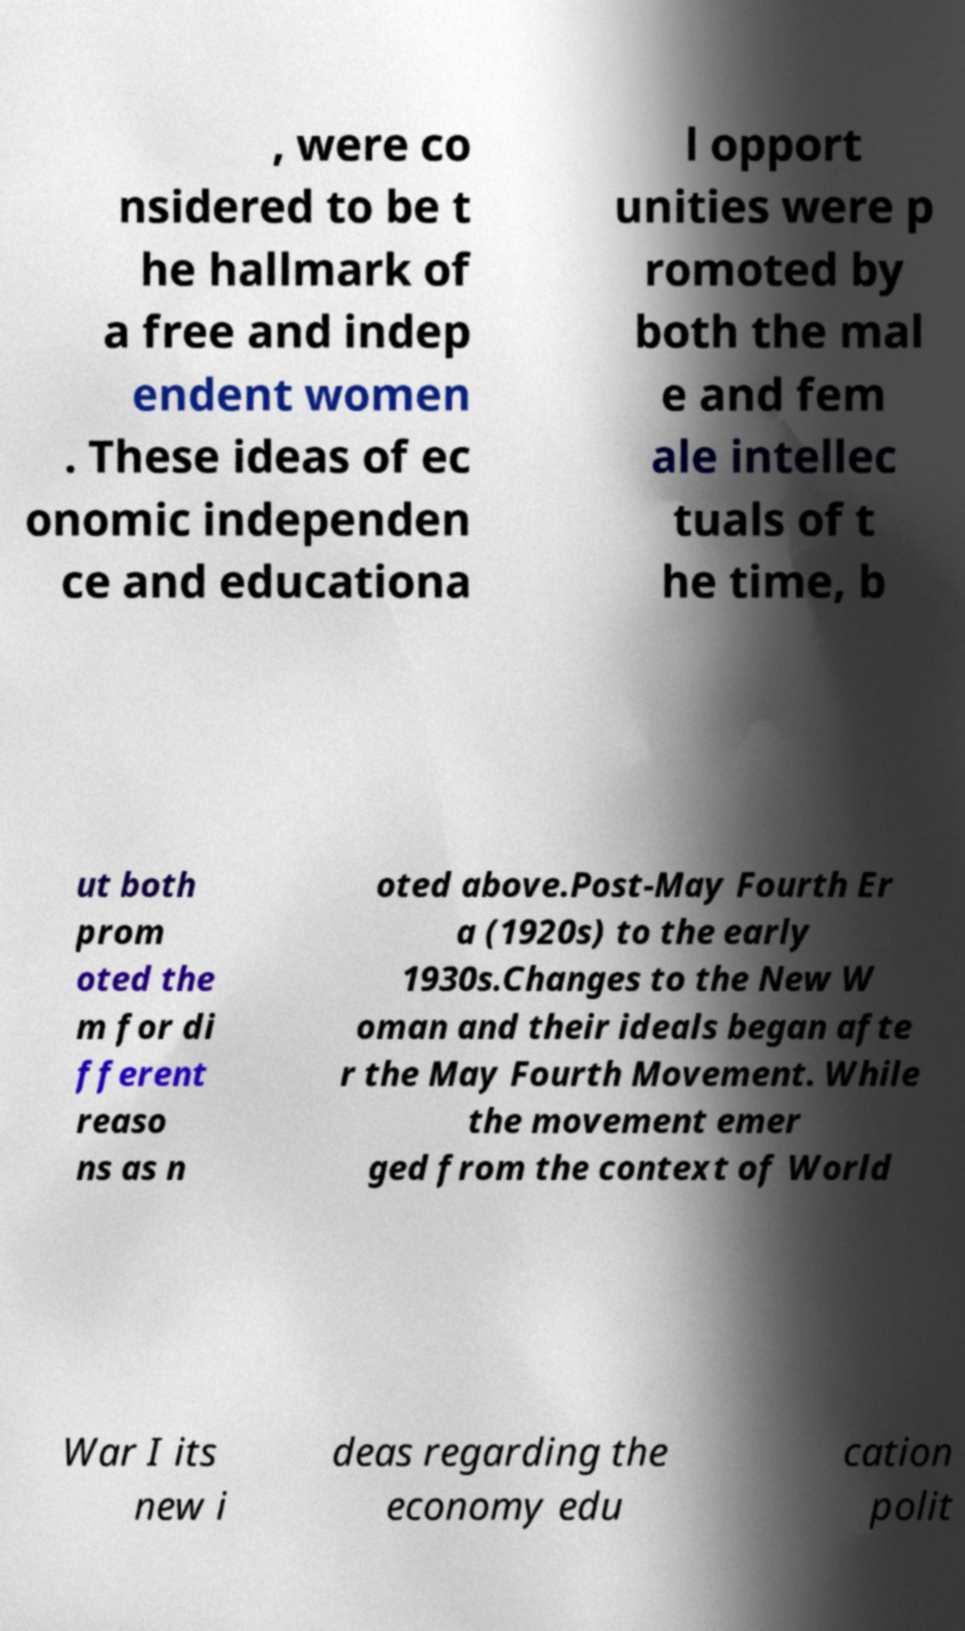What messages or text are displayed in this image? I need them in a readable, typed format. , were co nsidered to be t he hallmark of a free and indep endent women . These ideas of ec onomic independen ce and educationa l opport unities were p romoted by both the mal e and fem ale intellec tuals of t he time, b ut both prom oted the m for di fferent reaso ns as n oted above.Post-May Fourth Er a (1920s) to the early 1930s.Changes to the New W oman and their ideals began afte r the May Fourth Movement. While the movement emer ged from the context of World War I its new i deas regarding the economy edu cation polit 